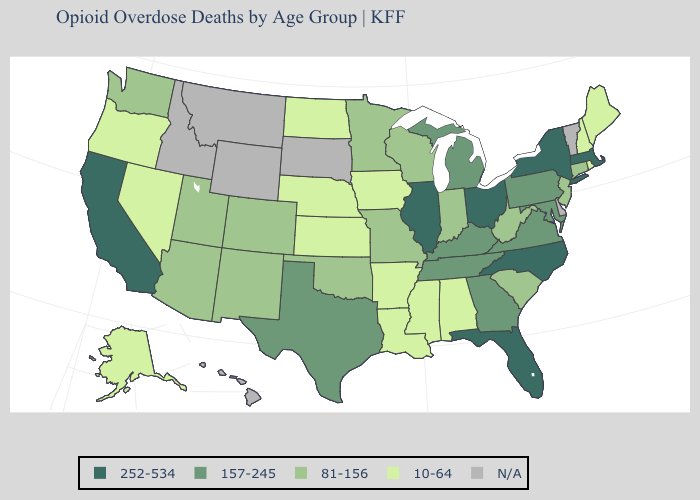Which states have the highest value in the USA?
Quick response, please. California, Florida, Illinois, Massachusetts, New York, North Carolina, Ohio. Among the states that border Idaho , does Washington have the highest value?
Quick response, please. Yes. Name the states that have a value in the range N/A?
Short answer required. Delaware, Hawaii, Idaho, Montana, South Dakota, Vermont, Wyoming. Which states have the highest value in the USA?
Concise answer only. California, Florida, Illinois, Massachusetts, New York, North Carolina, Ohio. Which states have the highest value in the USA?
Keep it brief. California, Florida, Illinois, Massachusetts, New York, North Carolina, Ohio. Name the states that have a value in the range N/A?
Concise answer only. Delaware, Hawaii, Idaho, Montana, South Dakota, Vermont, Wyoming. What is the lowest value in the West?
Quick response, please. 10-64. Among the states that border Georgia , which have the lowest value?
Give a very brief answer. Alabama. Name the states that have a value in the range 157-245?
Write a very short answer. Georgia, Kentucky, Maryland, Michigan, Pennsylvania, Tennessee, Texas, Virginia. What is the value of Idaho?
Be succinct. N/A. What is the value of New York?
Quick response, please. 252-534. Name the states that have a value in the range 10-64?
Write a very short answer. Alabama, Alaska, Arkansas, Iowa, Kansas, Louisiana, Maine, Mississippi, Nebraska, Nevada, New Hampshire, North Dakota, Oregon, Rhode Island. Which states have the lowest value in the MidWest?
Give a very brief answer. Iowa, Kansas, Nebraska, North Dakota. What is the value of New York?
Give a very brief answer. 252-534. 